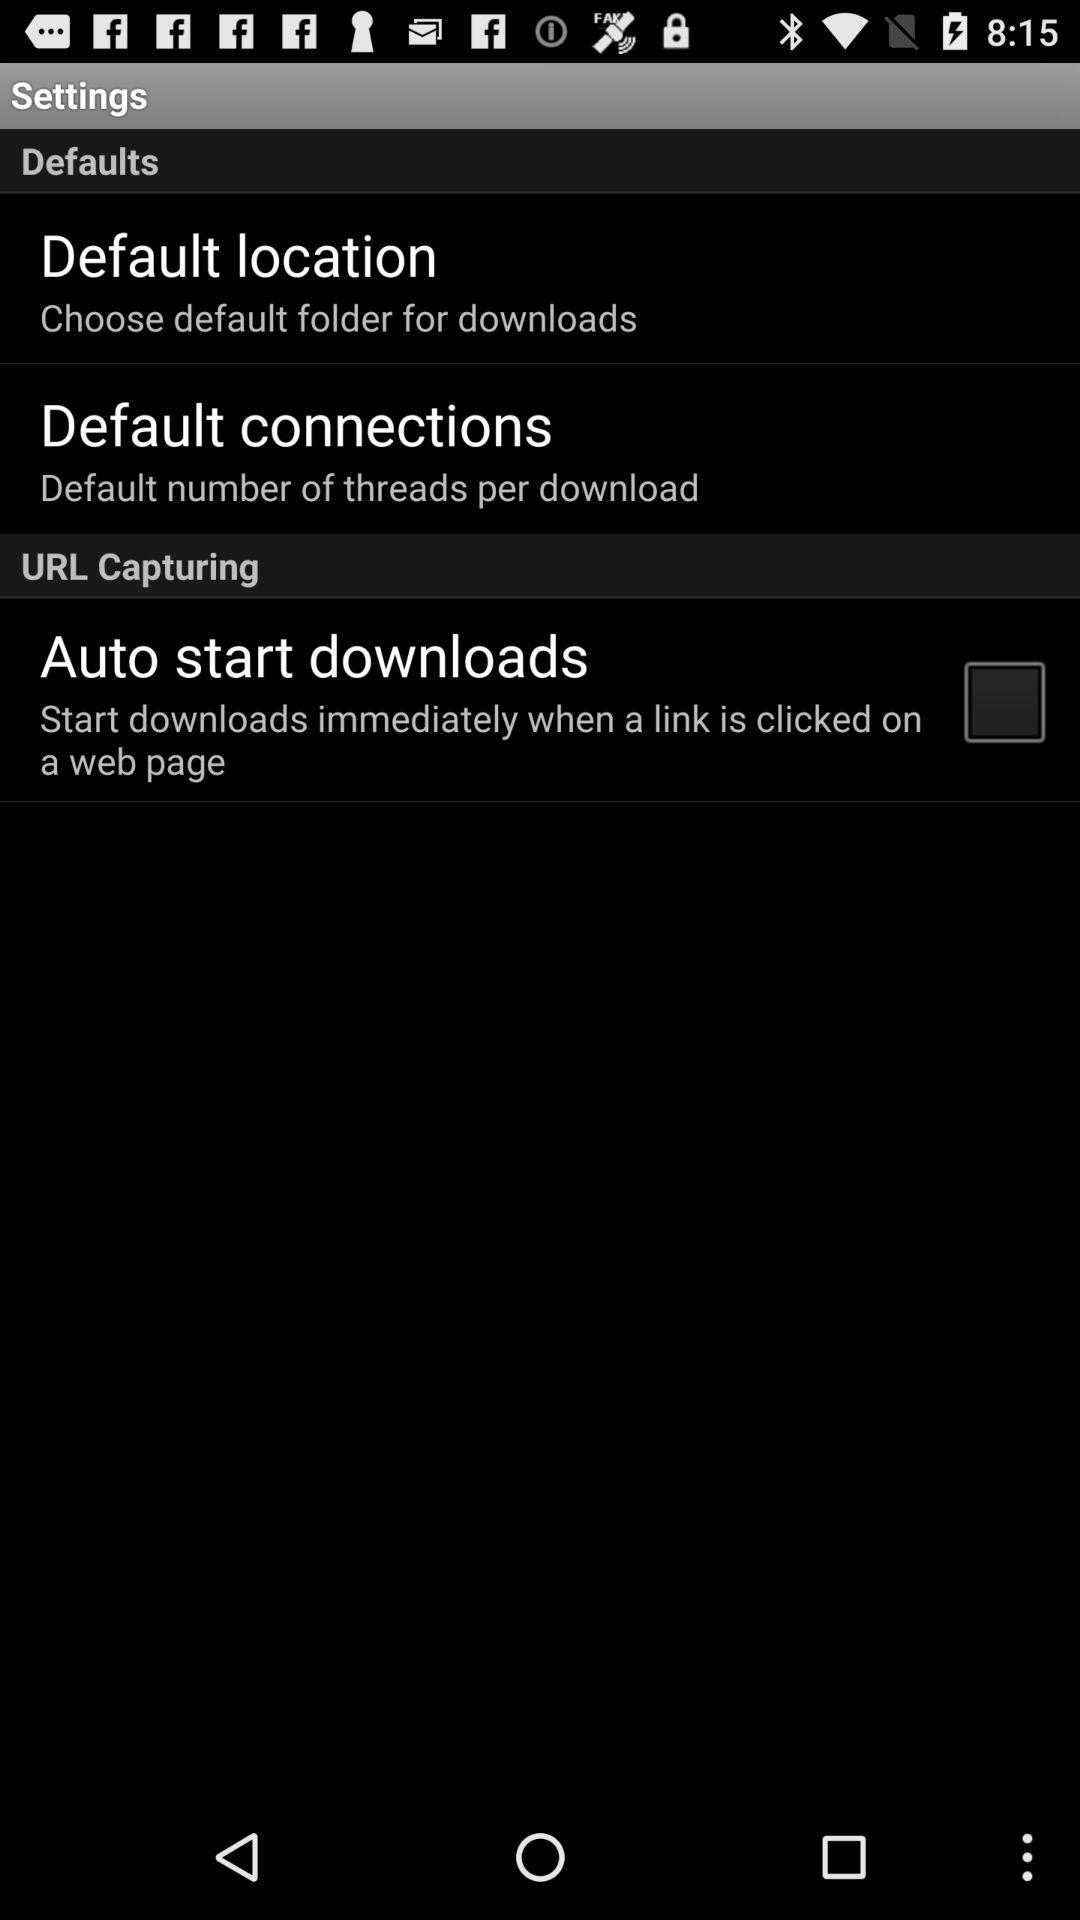What is the name of the application?
When the provided information is insufficient, respond with <no answer>. <no answer> 